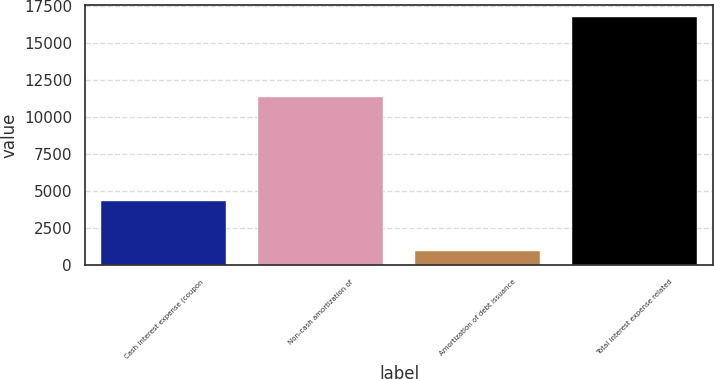Convert chart. <chart><loc_0><loc_0><loc_500><loc_500><bar_chart><fcel>Cash interest expense (coupon<fcel>Non-cash amortization of<fcel>Amortization of debt issuance<fcel>Total interest expense related<nl><fcel>4375<fcel>11372<fcel>1005<fcel>16752<nl></chart> 